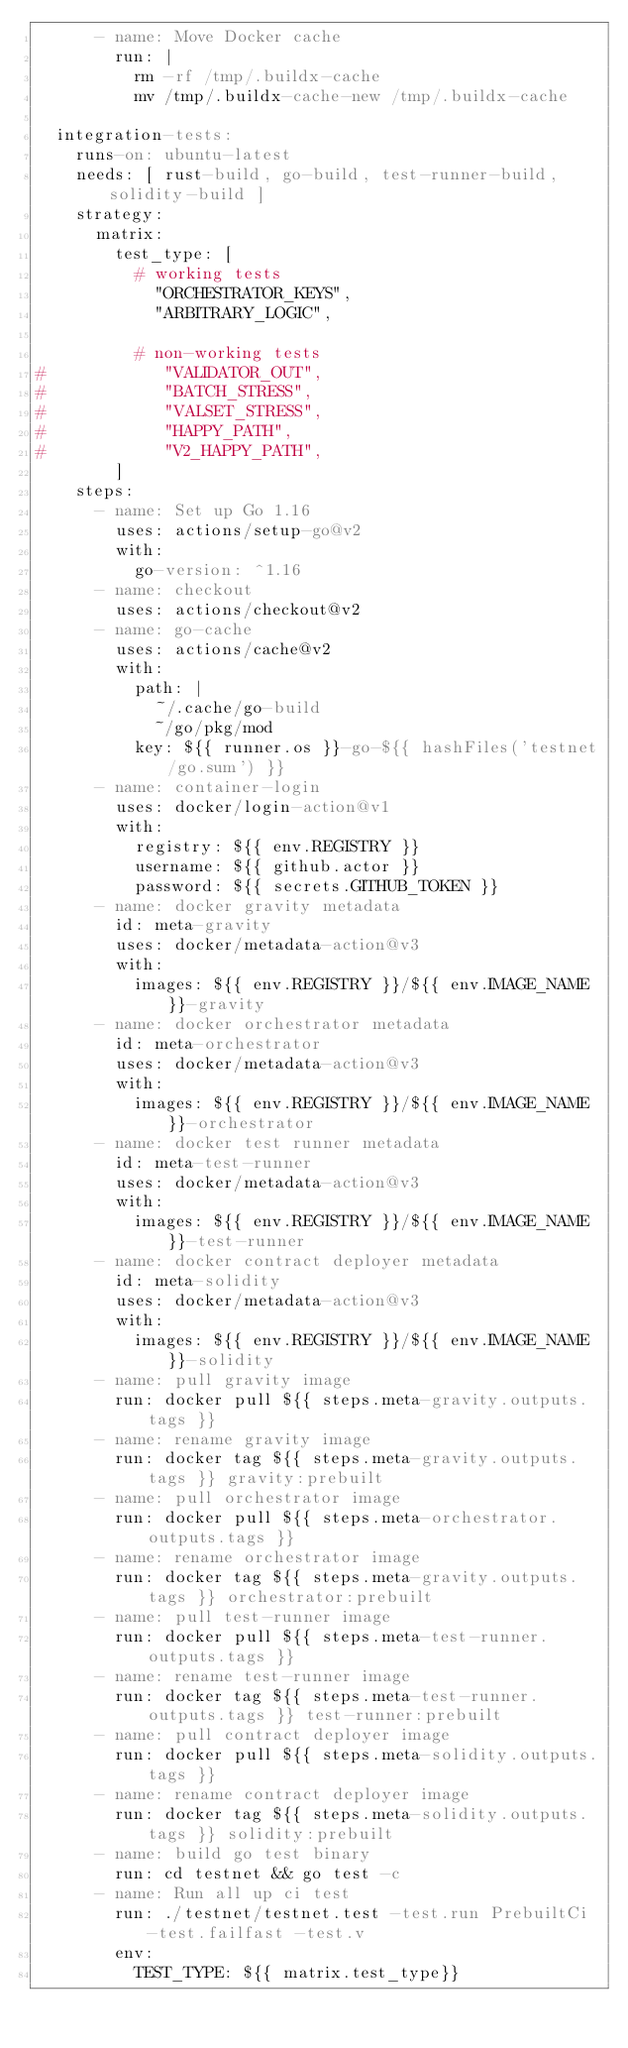<code> <loc_0><loc_0><loc_500><loc_500><_YAML_>      - name: Move Docker cache
        run: |
          rm -rf /tmp/.buildx-cache
          mv /tmp/.buildx-cache-new /tmp/.buildx-cache

  integration-tests:
    runs-on: ubuntu-latest
    needs: [ rust-build, go-build, test-runner-build, solidity-build ]
    strategy:
      matrix:
        test_type: [
          # working tests
            "ORCHESTRATOR_KEYS",
            "ARBITRARY_LOGIC",

          # non-working tests
#            "VALIDATOR_OUT",
#            "BATCH_STRESS",
#            "VALSET_STRESS",
#            "HAPPY_PATH",
#            "V2_HAPPY_PATH",
        ]
    steps:
      - name: Set up Go 1.16
        uses: actions/setup-go@v2
        with:
          go-version: ^1.16
      - name: checkout
        uses: actions/checkout@v2
      - name: go-cache
        uses: actions/cache@v2
        with:
          path: |
            ~/.cache/go-build
            ~/go/pkg/mod
          key: ${{ runner.os }}-go-${{ hashFiles('testnet/go.sum') }}
      - name: container-login
        uses: docker/login-action@v1
        with:
          registry: ${{ env.REGISTRY }}
          username: ${{ github.actor }}
          password: ${{ secrets.GITHUB_TOKEN }}
      - name: docker gravity metadata
        id: meta-gravity
        uses: docker/metadata-action@v3
        with:
          images: ${{ env.REGISTRY }}/${{ env.IMAGE_NAME }}-gravity
      - name: docker orchestrator metadata
        id: meta-orchestrator
        uses: docker/metadata-action@v3
        with:
          images: ${{ env.REGISTRY }}/${{ env.IMAGE_NAME }}-orchestrator
      - name: docker test runner metadata
        id: meta-test-runner
        uses: docker/metadata-action@v3
        with:
          images: ${{ env.REGISTRY }}/${{ env.IMAGE_NAME }}-test-runner
      - name: docker contract deployer metadata
        id: meta-solidity
        uses: docker/metadata-action@v3
        with:
          images: ${{ env.REGISTRY }}/${{ env.IMAGE_NAME }}-solidity
      - name: pull gravity image
        run: docker pull ${{ steps.meta-gravity.outputs.tags }}
      - name: rename gravity image
        run: docker tag ${{ steps.meta-gravity.outputs.tags }} gravity:prebuilt
      - name: pull orchestrator image
        run: docker pull ${{ steps.meta-orchestrator.outputs.tags }}
      - name: rename orchestrator image
        run: docker tag ${{ steps.meta-gravity.outputs.tags }} orchestrator:prebuilt
      - name: pull test-runner image
        run: docker pull ${{ steps.meta-test-runner.outputs.tags }}
      - name: rename test-runner image
        run: docker tag ${{ steps.meta-test-runner.outputs.tags }} test-runner:prebuilt
      - name: pull contract deployer image
        run: docker pull ${{ steps.meta-solidity.outputs.tags }}
      - name: rename contract deployer image
        run: docker tag ${{ steps.meta-solidity.outputs.tags }} solidity:prebuilt
      - name: build go test binary
        run: cd testnet && go test -c
      - name: Run all up ci test
        run: ./testnet/testnet.test -test.run PrebuiltCi -test.failfast -test.v
        env:
          TEST_TYPE: ${{ matrix.test_type}}</code> 